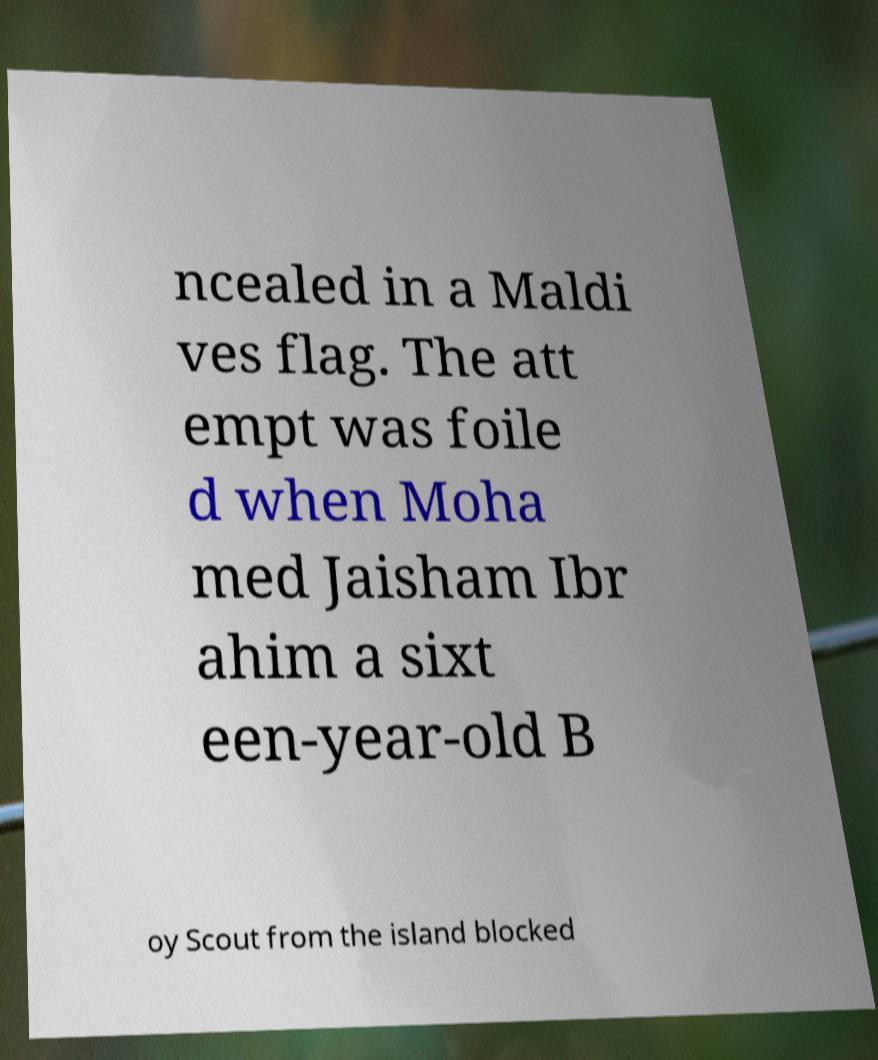What messages or text are displayed in this image? I need them in a readable, typed format. ncealed in a Maldi ves flag. The att empt was foile d when Moha med Jaisham Ibr ahim a sixt een-year-old B oy Scout from the island blocked 